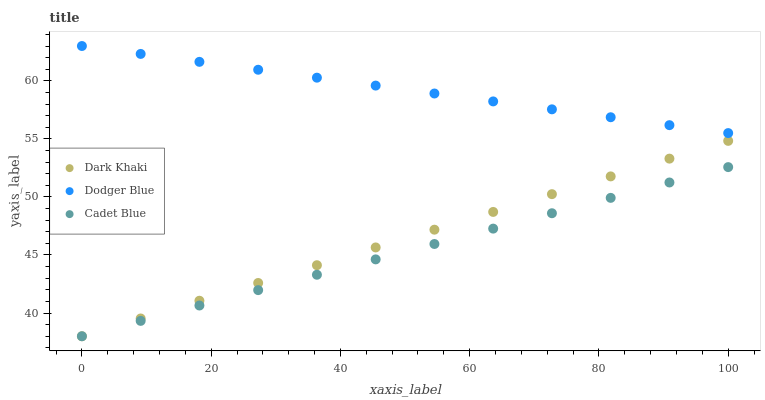Does Cadet Blue have the minimum area under the curve?
Answer yes or no. Yes. Does Dodger Blue have the maximum area under the curve?
Answer yes or no. Yes. Does Dodger Blue have the minimum area under the curve?
Answer yes or no. No. Does Cadet Blue have the maximum area under the curve?
Answer yes or no. No. Is Dodger Blue the smoothest?
Answer yes or no. Yes. Is Dark Khaki the roughest?
Answer yes or no. Yes. Is Cadet Blue the smoothest?
Answer yes or no. No. Is Cadet Blue the roughest?
Answer yes or no. No. Does Dark Khaki have the lowest value?
Answer yes or no. Yes. Does Dodger Blue have the lowest value?
Answer yes or no. No. Does Dodger Blue have the highest value?
Answer yes or no. Yes. Does Cadet Blue have the highest value?
Answer yes or no. No. Is Cadet Blue less than Dodger Blue?
Answer yes or no. Yes. Is Dodger Blue greater than Cadet Blue?
Answer yes or no. Yes. Does Dark Khaki intersect Cadet Blue?
Answer yes or no. Yes. Is Dark Khaki less than Cadet Blue?
Answer yes or no. No. Is Dark Khaki greater than Cadet Blue?
Answer yes or no. No. Does Cadet Blue intersect Dodger Blue?
Answer yes or no. No. 